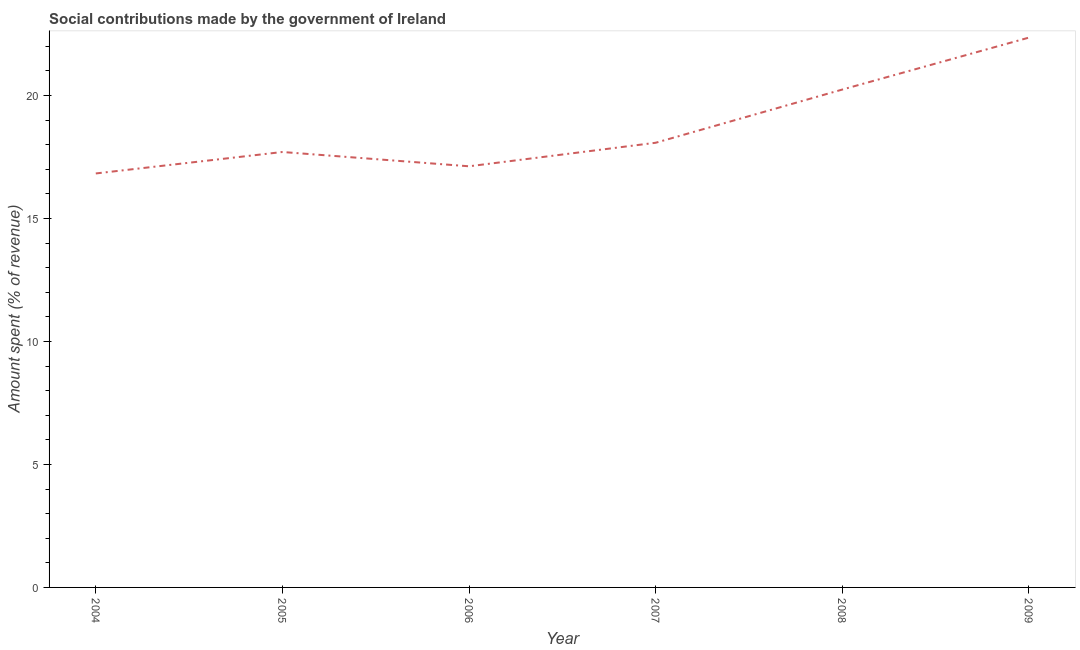What is the amount spent in making social contributions in 2006?
Give a very brief answer. 17.12. Across all years, what is the maximum amount spent in making social contributions?
Your answer should be compact. 22.35. Across all years, what is the minimum amount spent in making social contributions?
Keep it short and to the point. 16.83. In which year was the amount spent in making social contributions maximum?
Your response must be concise. 2009. In which year was the amount spent in making social contributions minimum?
Ensure brevity in your answer.  2004. What is the sum of the amount spent in making social contributions?
Ensure brevity in your answer.  112.33. What is the difference between the amount spent in making social contributions in 2006 and 2008?
Provide a succinct answer. -3.12. What is the average amount spent in making social contributions per year?
Make the answer very short. 18.72. What is the median amount spent in making social contributions?
Your answer should be very brief. 17.89. Do a majority of the years between 2006 and 2004 (inclusive) have amount spent in making social contributions greater than 17 %?
Your answer should be compact. No. What is the ratio of the amount spent in making social contributions in 2005 to that in 2008?
Keep it short and to the point. 0.87. Is the difference between the amount spent in making social contributions in 2005 and 2007 greater than the difference between any two years?
Provide a succinct answer. No. What is the difference between the highest and the second highest amount spent in making social contributions?
Provide a short and direct response. 2.11. What is the difference between the highest and the lowest amount spent in making social contributions?
Provide a succinct answer. 5.52. Does the amount spent in making social contributions monotonically increase over the years?
Your answer should be very brief. No. What is the difference between two consecutive major ticks on the Y-axis?
Your response must be concise. 5. Are the values on the major ticks of Y-axis written in scientific E-notation?
Give a very brief answer. No. Does the graph contain grids?
Provide a short and direct response. No. What is the title of the graph?
Ensure brevity in your answer.  Social contributions made by the government of Ireland. What is the label or title of the X-axis?
Keep it short and to the point. Year. What is the label or title of the Y-axis?
Provide a short and direct response. Amount spent (% of revenue). What is the Amount spent (% of revenue) of 2004?
Make the answer very short. 16.83. What is the Amount spent (% of revenue) in 2005?
Your answer should be very brief. 17.7. What is the Amount spent (% of revenue) in 2006?
Give a very brief answer. 17.12. What is the Amount spent (% of revenue) in 2007?
Provide a short and direct response. 18.08. What is the Amount spent (% of revenue) in 2008?
Keep it short and to the point. 20.24. What is the Amount spent (% of revenue) in 2009?
Ensure brevity in your answer.  22.35. What is the difference between the Amount spent (% of revenue) in 2004 and 2005?
Ensure brevity in your answer.  -0.87. What is the difference between the Amount spent (% of revenue) in 2004 and 2006?
Make the answer very short. -0.29. What is the difference between the Amount spent (% of revenue) in 2004 and 2007?
Provide a short and direct response. -1.25. What is the difference between the Amount spent (% of revenue) in 2004 and 2008?
Give a very brief answer. -3.41. What is the difference between the Amount spent (% of revenue) in 2004 and 2009?
Your answer should be compact. -5.52. What is the difference between the Amount spent (% of revenue) in 2005 and 2006?
Your answer should be compact. 0.58. What is the difference between the Amount spent (% of revenue) in 2005 and 2007?
Your answer should be compact. -0.38. What is the difference between the Amount spent (% of revenue) in 2005 and 2008?
Offer a terse response. -2.54. What is the difference between the Amount spent (% of revenue) in 2005 and 2009?
Keep it short and to the point. -4.65. What is the difference between the Amount spent (% of revenue) in 2006 and 2007?
Give a very brief answer. -0.96. What is the difference between the Amount spent (% of revenue) in 2006 and 2008?
Provide a short and direct response. -3.12. What is the difference between the Amount spent (% of revenue) in 2006 and 2009?
Your answer should be compact. -5.23. What is the difference between the Amount spent (% of revenue) in 2007 and 2008?
Give a very brief answer. -2.16. What is the difference between the Amount spent (% of revenue) in 2007 and 2009?
Offer a terse response. -4.28. What is the difference between the Amount spent (% of revenue) in 2008 and 2009?
Provide a short and direct response. -2.11. What is the ratio of the Amount spent (% of revenue) in 2004 to that in 2005?
Ensure brevity in your answer.  0.95. What is the ratio of the Amount spent (% of revenue) in 2004 to that in 2006?
Provide a succinct answer. 0.98. What is the ratio of the Amount spent (% of revenue) in 2004 to that in 2007?
Offer a very short reply. 0.93. What is the ratio of the Amount spent (% of revenue) in 2004 to that in 2008?
Give a very brief answer. 0.83. What is the ratio of the Amount spent (% of revenue) in 2004 to that in 2009?
Make the answer very short. 0.75. What is the ratio of the Amount spent (% of revenue) in 2005 to that in 2006?
Offer a terse response. 1.03. What is the ratio of the Amount spent (% of revenue) in 2005 to that in 2007?
Your answer should be compact. 0.98. What is the ratio of the Amount spent (% of revenue) in 2005 to that in 2009?
Ensure brevity in your answer.  0.79. What is the ratio of the Amount spent (% of revenue) in 2006 to that in 2007?
Give a very brief answer. 0.95. What is the ratio of the Amount spent (% of revenue) in 2006 to that in 2008?
Your answer should be compact. 0.85. What is the ratio of the Amount spent (% of revenue) in 2006 to that in 2009?
Keep it short and to the point. 0.77. What is the ratio of the Amount spent (% of revenue) in 2007 to that in 2008?
Keep it short and to the point. 0.89. What is the ratio of the Amount spent (% of revenue) in 2007 to that in 2009?
Your response must be concise. 0.81. What is the ratio of the Amount spent (% of revenue) in 2008 to that in 2009?
Ensure brevity in your answer.  0.91. 